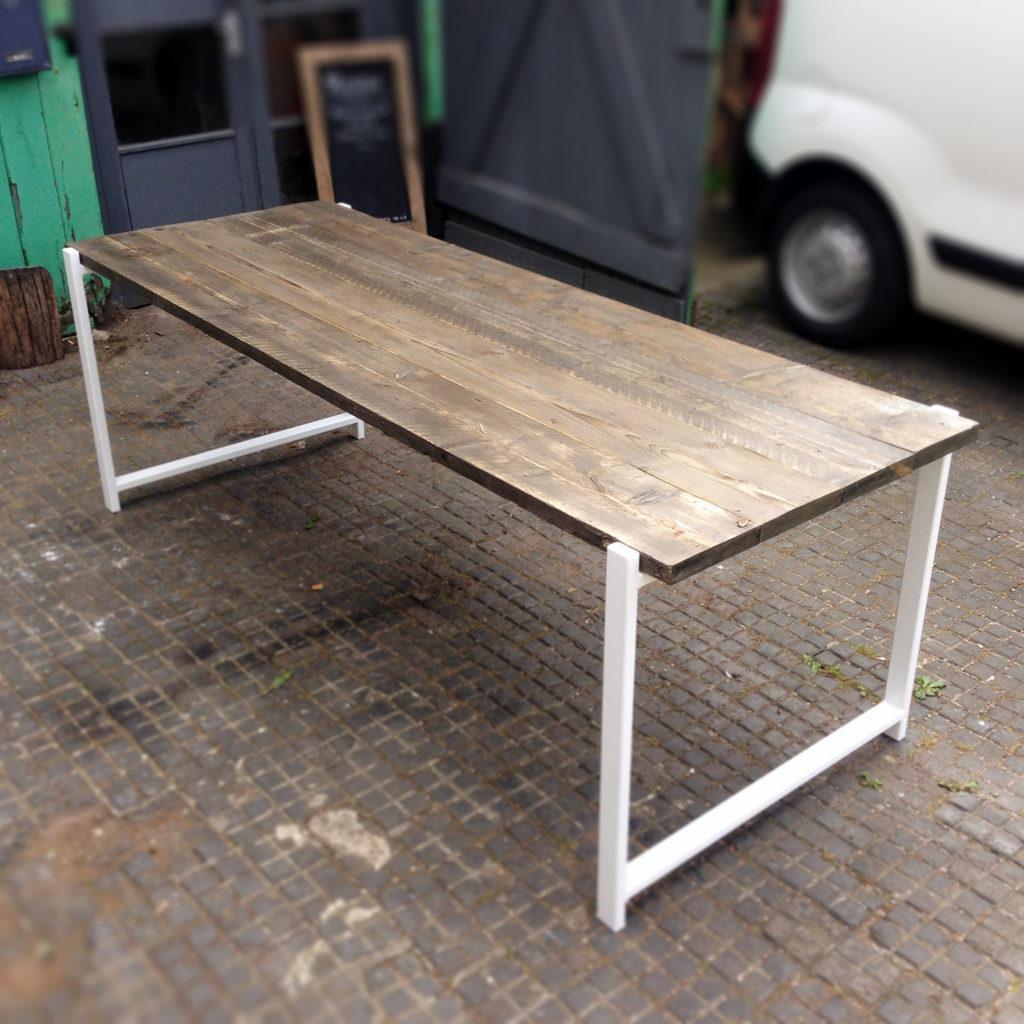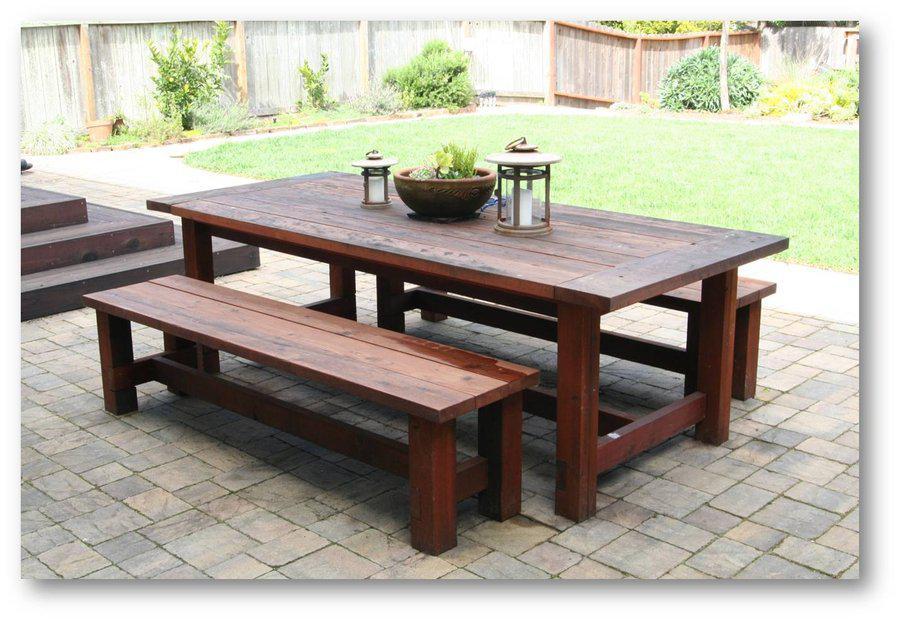The first image is the image on the left, the second image is the image on the right. Given the left and right images, does the statement "In one image, a rectangular wooden table has two long bench seats, one on each side." hold true? Answer yes or no. Yes. 